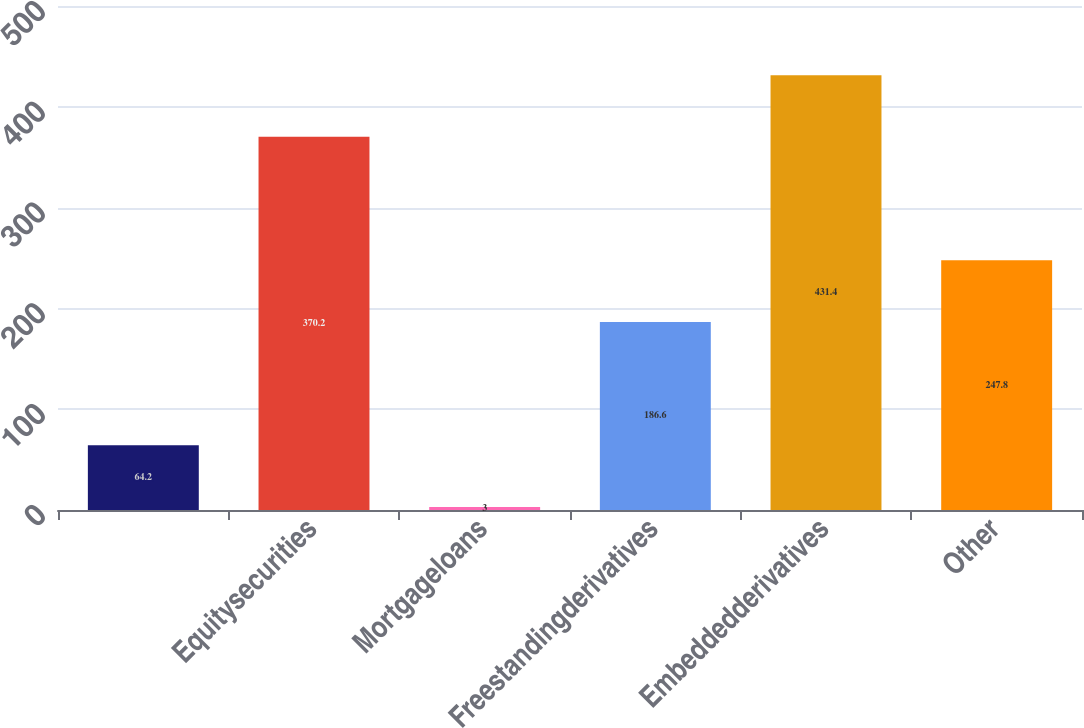Convert chart to OTSL. <chart><loc_0><loc_0><loc_500><loc_500><bar_chart><ecel><fcel>Equitysecurities<fcel>Mortgageloans<fcel>Freestandingderivatives<fcel>Embeddedderivatives<fcel>Other<nl><fcel>64.2<fcel>370.2<fcel>3<fcel>186.6<fcel>431.4<fcel>247.8<nl></chart> 